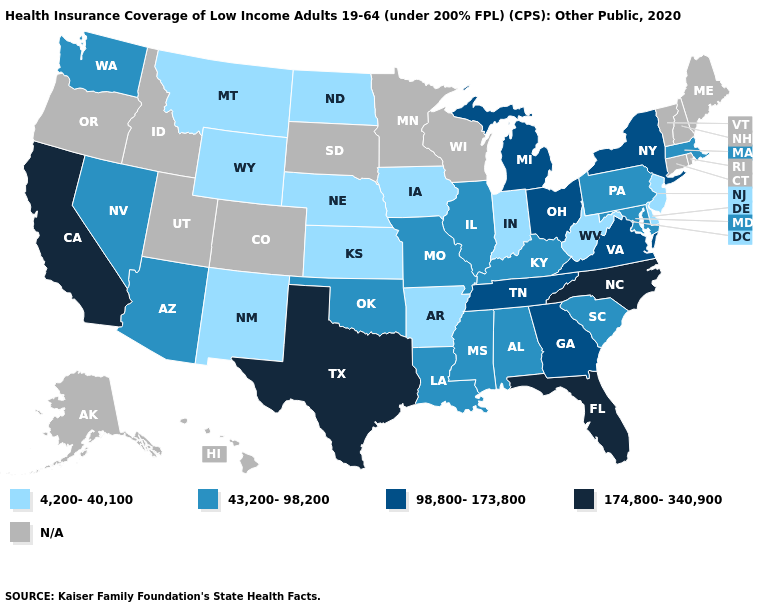What is the value of Idaho?
Write a very short answer. N/A. Does the first symbol in the legend represent the smallest category?
Short answer required. Yes. Among the states that border Nebraska , which have the lowest value?
Keep it brief. Iowa, Kansas, Wyoming. Does the map have missing data?
Concise answer only. Yes. Does New Jersey have the lowest value in the Northeast?
Be succinct. Yes. Is the legend a continuous bar?
Be succinct. No. What is the lowest value in the USA?
Write a very short answer. 4,200-40,100. What is the highest value in the West ?
Keep it brief. 174,800-340,900. Name the states that have a value in the range 98,800-173,800?
Keep it brief. Georgia, Michigan, New York, Ohio, Tennessee, Virginia. Does the map have missing data?
Write a very short answer. Yes. What is the value of Ohio?
Give a very brief answer. 98,800-173,800. Among the states that border Iowa , which have the lowest value?
Keep it brief. Nebraska. Among the states that border Florida , which have the lowest value?
Write a very short answer. Alabama. 